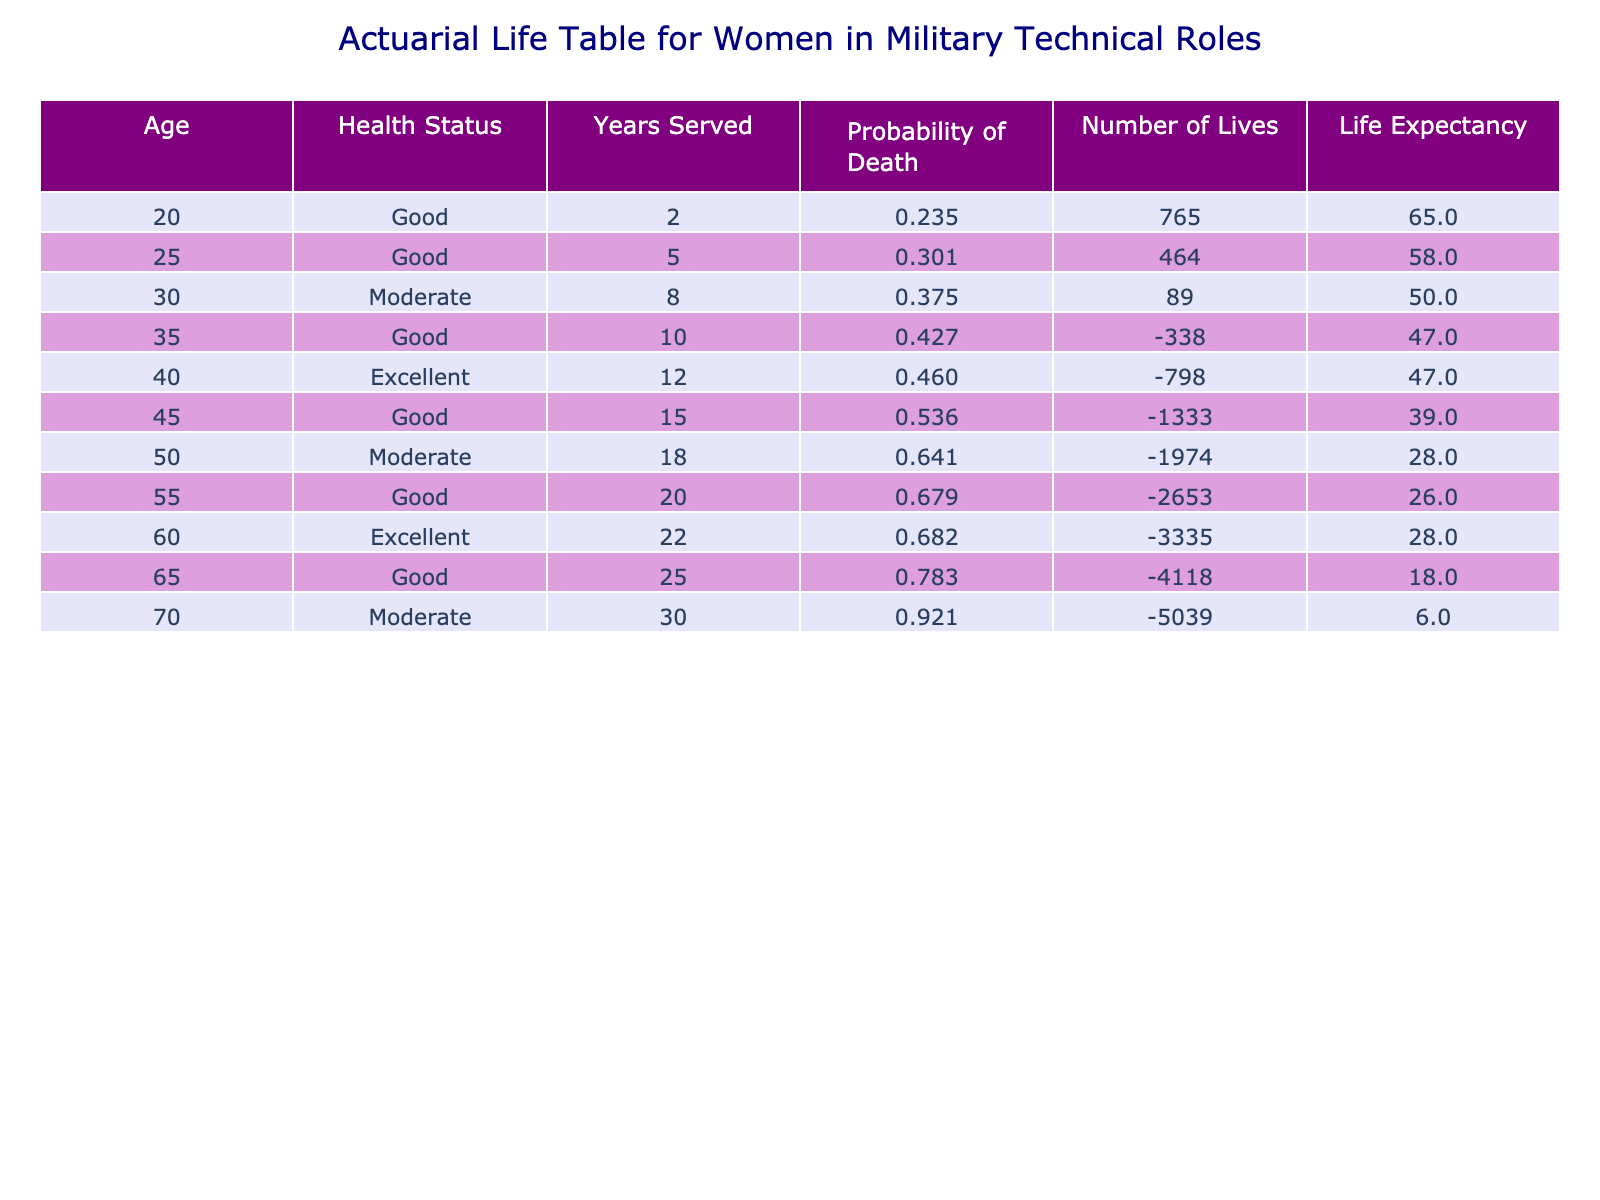What is the lifespan estimate for the 60-year-old female Civilian Aircraft Inspector? The table indicates that the lifespan estimate for the Civilian Aircraft Inspector at age 60 is 88.
Answer: 88 How many years did the 45-year-old Navy Repair Facility Supervisor serve? According to the table, the 45-year-old Navy Repair Facility Supervisor served for 15 years.
Answer: 15 What is the probability of death for the 30-year-old female in Aircraft Structural Repair? The table shows the lifespan estimate for the 30-year-old is 80. The probability of death is calculated as 1 - ((80 - 30) / 80) = 0.625.
Answer: 0.625 Which role has the highest lifespan estimate among women in military technical roles? Examining the lifespan estimates, the highest estimate is for the 60-year-old Civilian Aircraft Inspector with 88 years.
Answer: Civilian Aircraft Inspector What is the average lifespan estimate for females in good health status? The lifespan estimates for females in good health status are: 85, 83, 82, 87, 84, 81, and 88. The total is 85 + 83 + 82 + 87 + 84 + 81 + 88 = 510. Dividing by 7 gives an average of 510 / 7 ≈ 72.86.
Answer: 72.86 Does the 70-year-old Army Senior Technical Advisor have an excellent health status? Referring to the table, the health status listed for the 70-year-old Army Senior Technical Advisor is moderate, not excellent.
Answer: No If a female Avionics Technician served for 5 years, what is her life expectancy? The lifespan estimate for the 25-year-old Avionics Technician is 83 years. Her life expectancy is calculated as 83 - 25 = 58 years.
Answer: 58 What is the difference in lifespan estimate between the oldest and youngest females in the table? The youngest female is 20 years old with a lifespan estimate of 85, and the oldest is 70 years old with a lifespan estimate of 76. The difference is 85 - 76 = 9 years.
Answer: 9 Which females have served more than 20 years, and what is their average lifespan estimate? In the table, only the 65-year-old Navy Quality Assurance Inspector served 25 years. Her lifespan estimate is 83. Thus, the average lifespan here is just her lifespan estimate, which remains 83 years.
Answer: 83 